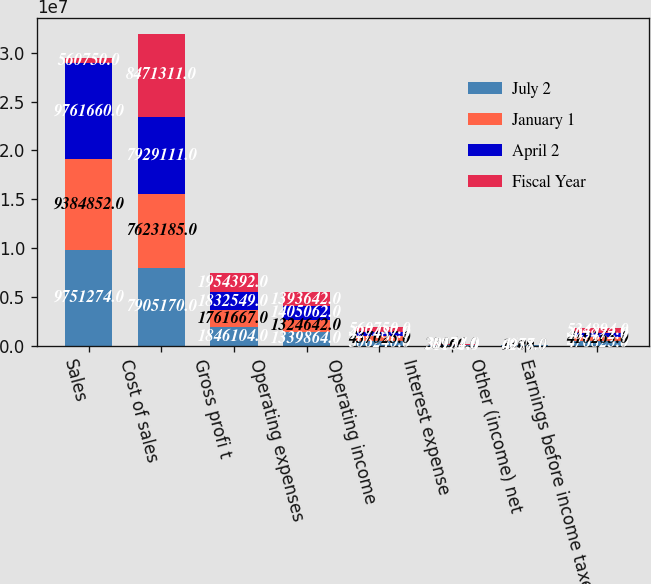Convert chart. <chart><loc_0><loc_0><loc_500><loc_500><stacked_bar_chart><ecel><fcel>Sales<fcel>Cost of sales<fcel>Gross profi t<fcel>Operating expenses<fcel>Operating income<fcel>Interest expense<fcel>Other (income) net<fcel>Earnings before income taxes<nl><fcel>July 2<fcel>9.75127e+06<fcel>7.90517e+06<fcel>1.8461e+06<fcel>1.33986e+06<fcel>506240<fcel>31101<fcel>1684<fcel>476823<nl><fcel>January 1<fcel>9.38485e+06<fcel>7.62318e+06<fcel>1.76167e+06<fcel>1.32464e+06<fcel>437025<fcel>28060<fcel>1300<fcel>410265<nl><fcel>April 2<fcel>9.76166e+06<fcel>7.92911e+06<fcel>1.83255e+06<fcel>1.40506e+06<fcel>427487<fcel>28972<fcel>6957<fcel>405472<nl><fcel>Fiscal Year<fcel>560750<fcel>8.47131e+06<fcel>1.95439e+06<fcel>1.39364e+06<fcel>560750<fcel>30134<fcel>4278<fcel>534894<nl></chart> 